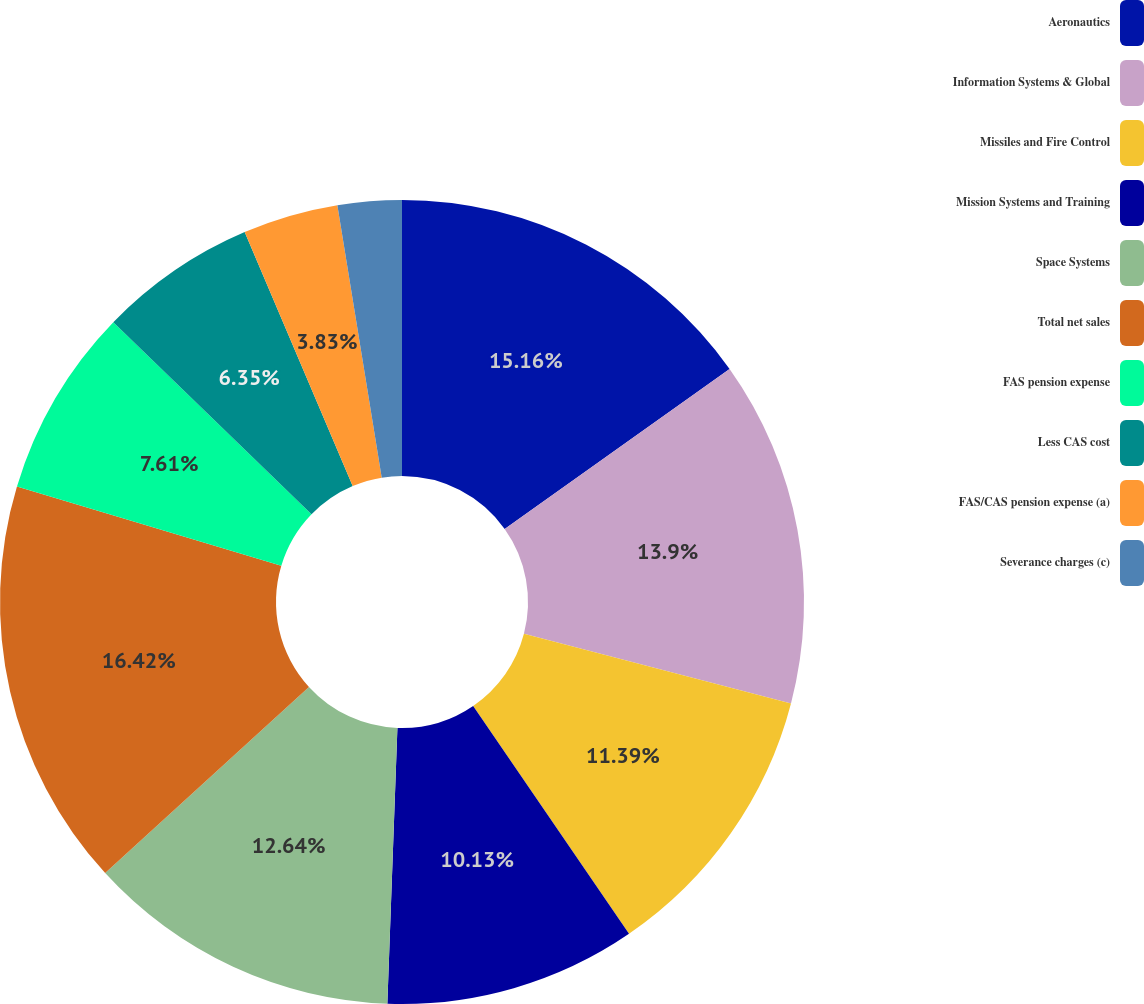<chart> <loc_0><loc_0><loc_500><loc_500><pie_chart><fcel>Aeronautics<fcel>Information Systems & Global<fcel>Missiles and Fire Control<fcel>Mission Systems and Training<fcel>Space Systems<fcel>Total net sales<fcel>FAS pension expense<fcel>Less CAS cost<fcel>FAS/CAS pension expense (a)<fcel>Severance charges (c)<nl><fcel>15.16%<fcel>13.9%<fcel>11.39%<fcel>10.13%<fcel>12.64%<fcel>16.42%<fcel>7.61%<fcel>6.35%<fcel>3.83%<fcel>2.57%<nl></chart> 